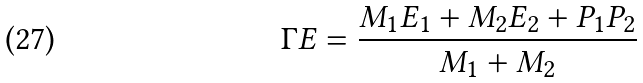<formula> <loc_0><loc_0><loc_500><loc_500>\Gamma E = { \frac { M _ { 1 } E _ { 1 } + M _ { 2 } E _ { 2 } + P _ { 1 } P _ { 2 } } { M _ { 1 } + M _ { 2 } } }</formula> 